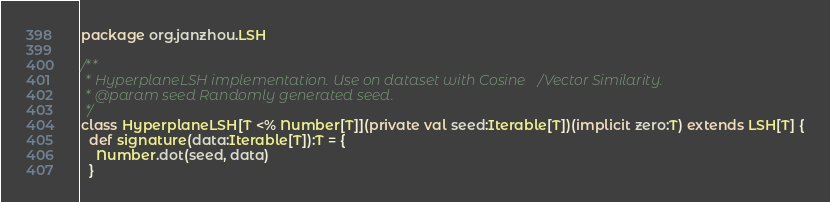<code> <loc_0><loc_0><loc_500><loc_500><_Scala_>package org.janzhou.LSH

/**
 * HyperplaneLSH implementation. Use on dataset with Cosine/Vector Similarity.
 * @param seed Randomly generated seed.
 */
class HyperplaneLSH[T <% Number[T]](private val seed:Iterable[T])(implicit zero:T) extends LSH[T] {
  def signature(data:Iterable[T]):T = {
    Number.dot(seed, data)
  }
</code> 